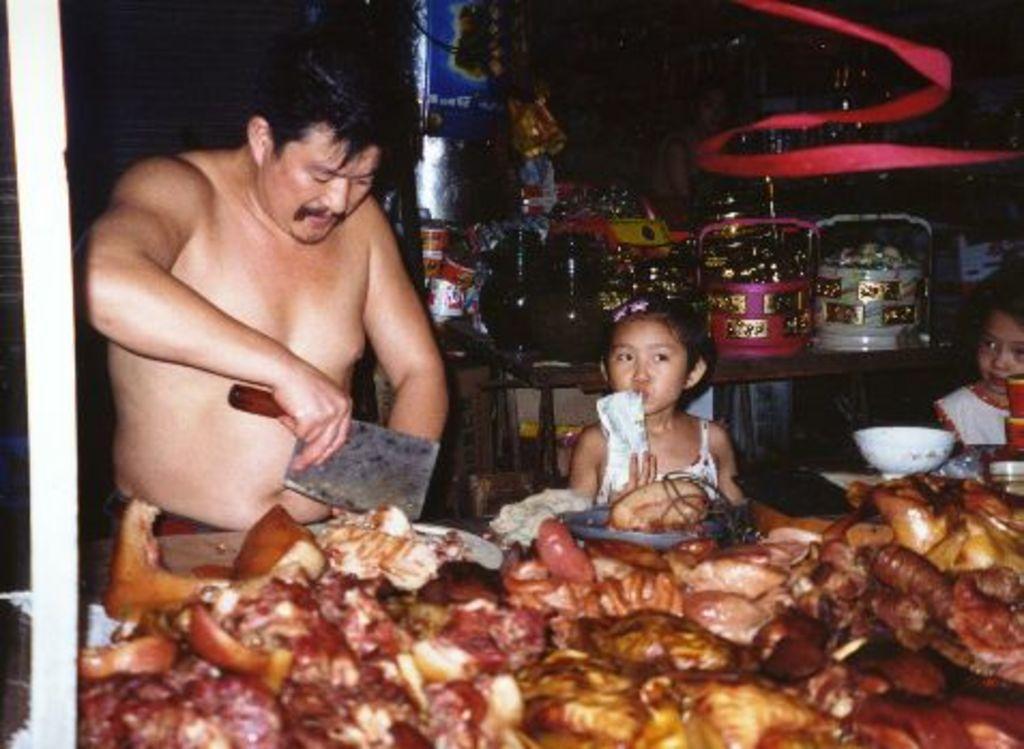In one or two sentences, can you explain what this image depicts? In this picture we can see three people, one person is holding a knife, in front of them we can see a cutting plank, bowls, meat and in the background we can see this, woman and some objects. 